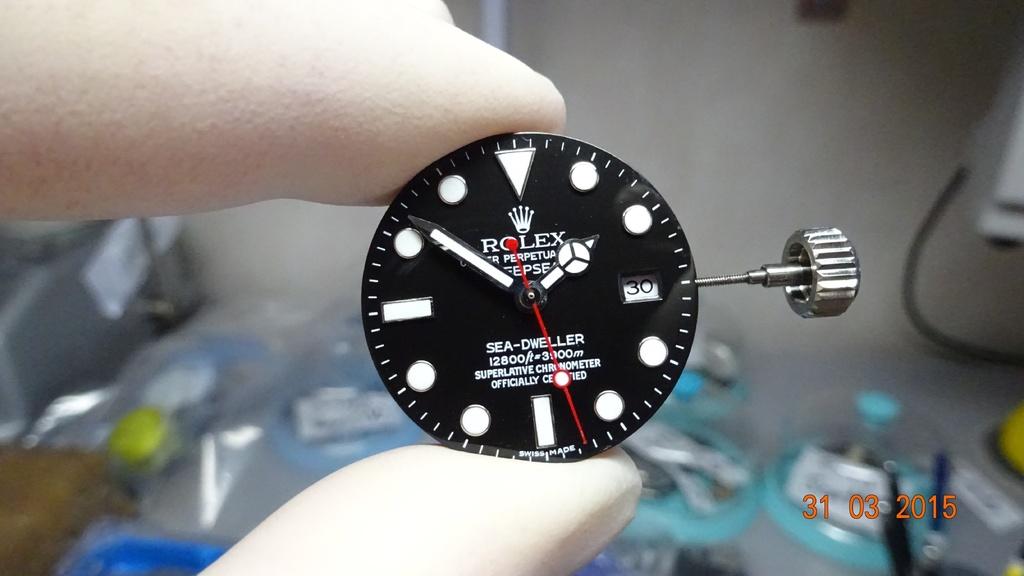When was this photo taken?
Give a very brief answer. 31 03 2015. What brand is this watch piece?
Your answer should be compact. Rolex. 